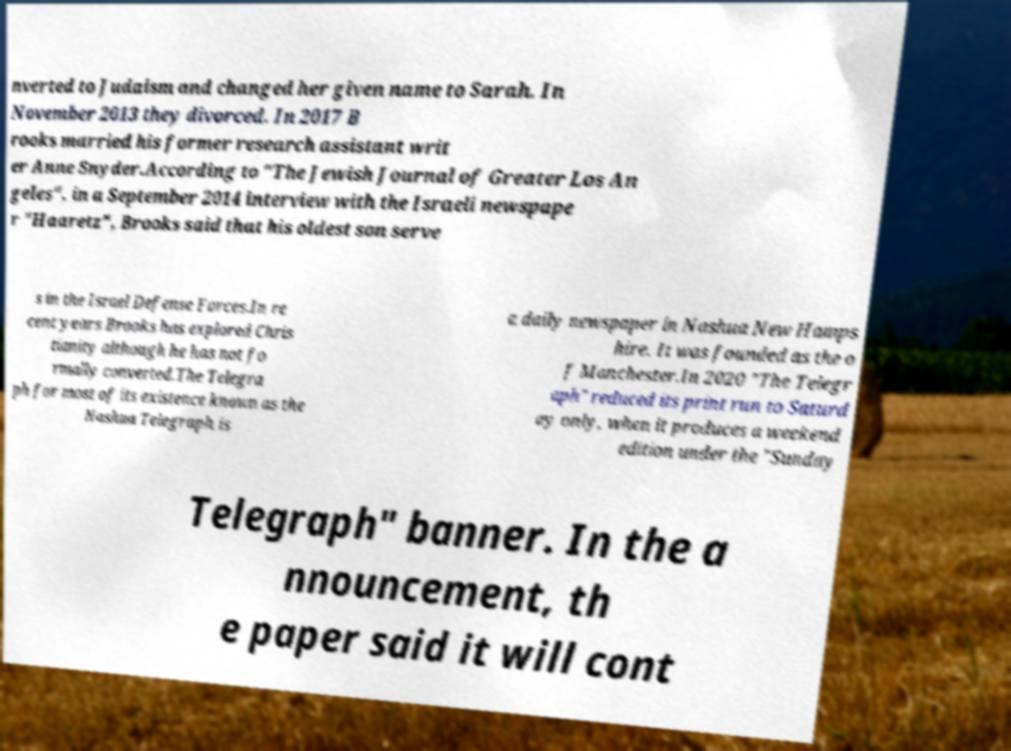Please identify and transcribe the text found in this image. nverted to Judaism and changed her given name to Sarah. In November 2013 they divorced. In 2017 B rooks married his former research assistant writ er Anne Snyder.According to "The Jewish Journal of Greater Los An geles", in a September 2014 interview with the Israeli newspape r "Haaretz", Brooks said that his oldest son serve s in the Israel Defense Forces.In re cent years Brooks has explored Chris tianity although he has not fo rmally converted.The Telegra ph for most of its existence known as the Nashua Telegraph is a daily newspaper in Nashua New Hamps hire. It was founded as the o f Manchester.In 2020 "The Telegr aph" reduced its print run to Saturd ay only, when it produces a weekend edition under the "Sunday Telegraph" banner. In the a nnouncement, th e paper said it will cont 